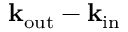Convert formula to latex. <formula><loc_0><loc_0><loc_500><loc_500>k _ { o u t } - k _ { i n }</formula> 